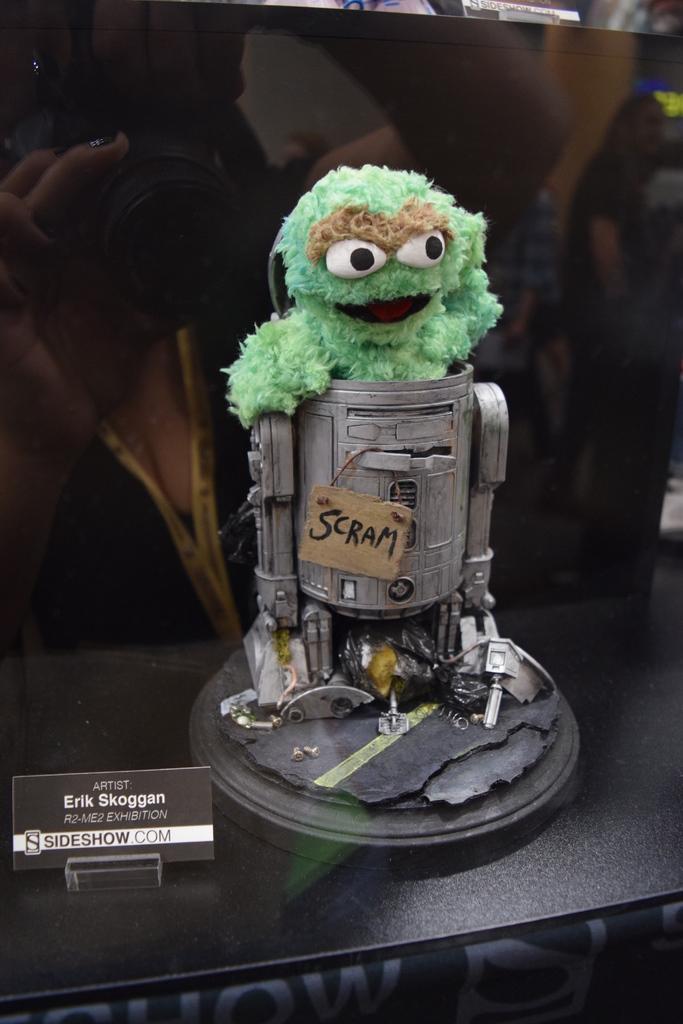Could you give a brief overview of what you see in this image? In this image, we can see a black color table. On the table, we can see a card, on the card, we can see some text written on it. In the middle of the table, we can see some metal instrument, in the metal instrument, we can see a toy. In the background, we can see black color. 